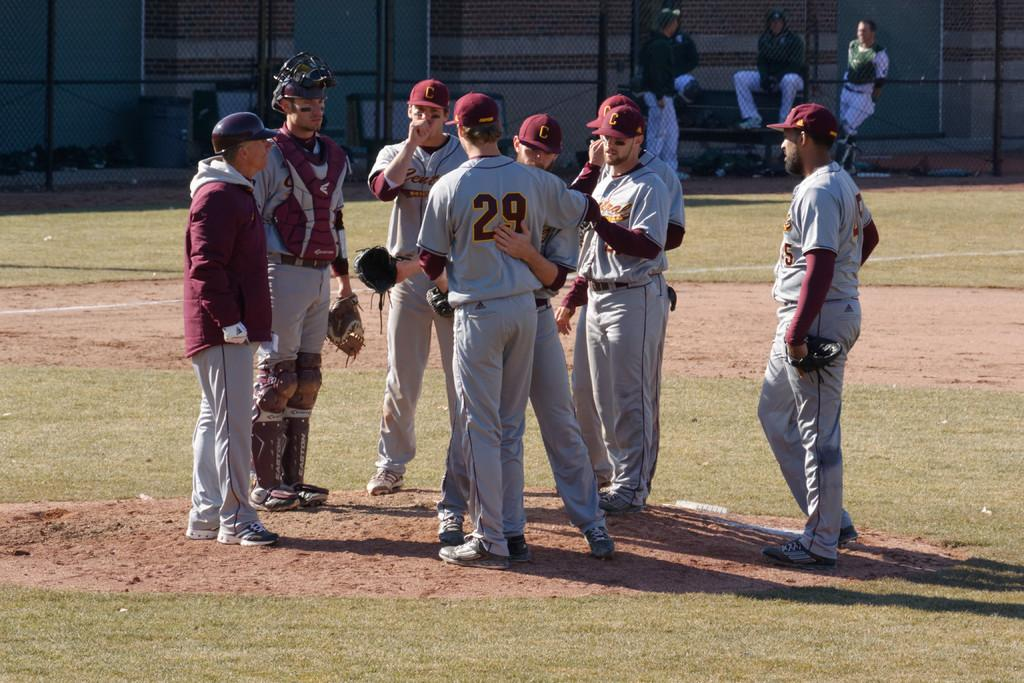Provide a one-sentence caption for the provided image. A group of basball players standing near the pitcher's mound and one player embracing player number 29. 